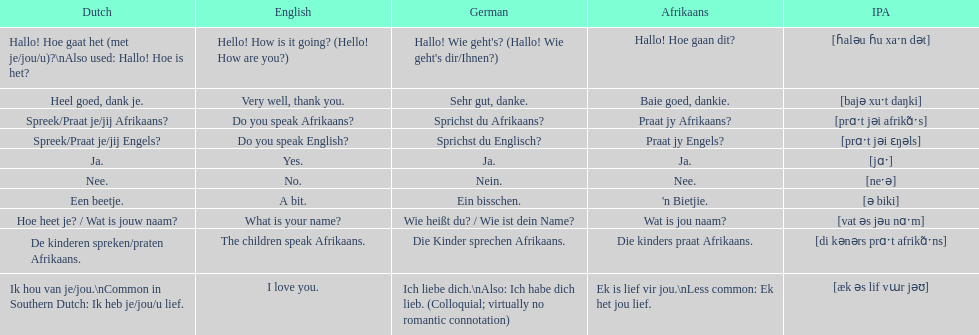Translate the following into german: die kinders praat afrikaans. Die Kinder sprechen Afrikaans. 